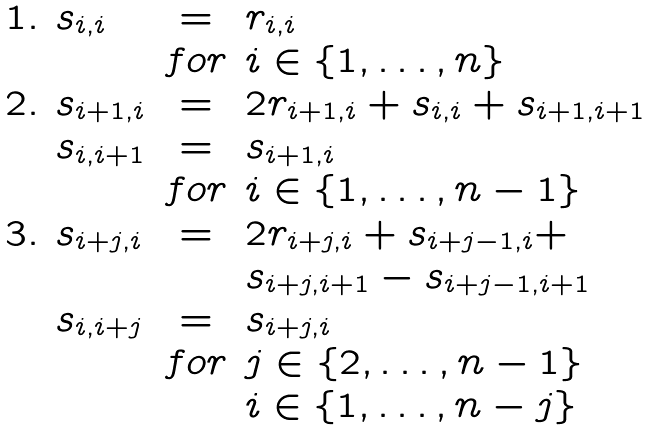<formula> <loc_0><loc_0><loc_500><loc_500>\begin{array} { l l c l } 1 . & s _ { i , i } & = & r _ { i , i } \\ & & f o r & i \in \{ 1 , \dots , n \} \\ 2 . & s _ { i + 1 , i } & = & 2 r _ { i + 1 , i } + s _ { i , i } + s _ { i + 1 , i + 1 } \\ & s _ { i , i + 1 } & = & s _ { i + 1 , i } \\ & & f o r & i \in \{ 1 , \dots , n - 1 \} \\ 3 . & s _ { i + j , i } & = & 2 r _ { i + j , i } + s _ { i + j - 1 , i } + \\ & & & s _ { i + j , i + 1 } - s _ { i + j - 1 , i + 1 } \\ & s _ { i , i + j } & = & s _ { i + j , i } \\ & & f o r & j \in \{ 2 , \dots , n - 1 \} \\ & & & i \in \{ 1 , \dots , n - j \} \\ \end{array}</formula> 